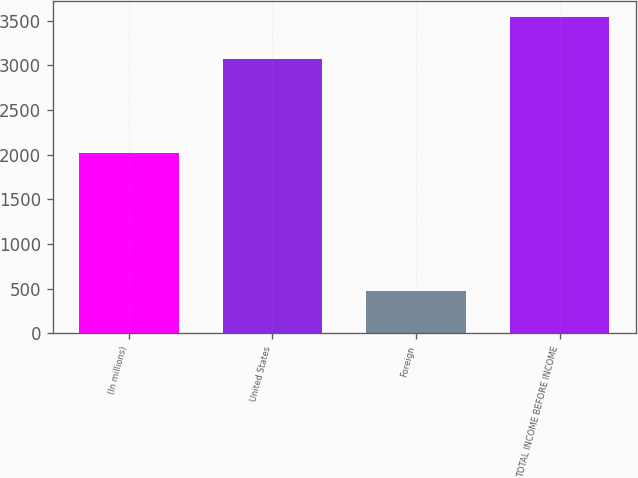Convert chart. <chart><loc_0><loc_0><loc_500><loc_500><bar_chart><fcel>(In millions)<fcel>United States<fcel>Foreign<fcel>TOTAL INCOME BEFORE INCOME<nl><fcel>2014<fcel>3066<fcel>478<fcel>3544<nl></chart> 